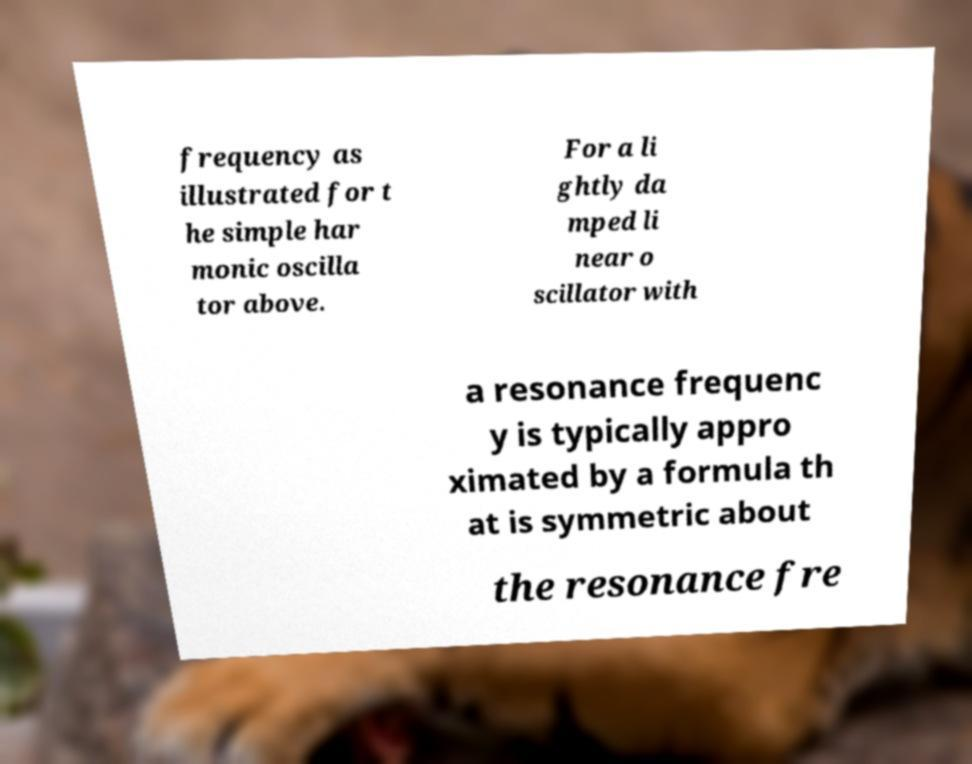I need the written content from this picture converted into text. Can you do that? frequency as illustrated for t he simple har monic oscilla tor above. For a li ghtly da mped li near o scillator with a resonance frequenc y is typically appro ximated by a formula th at is symmetric about the resonance fre 